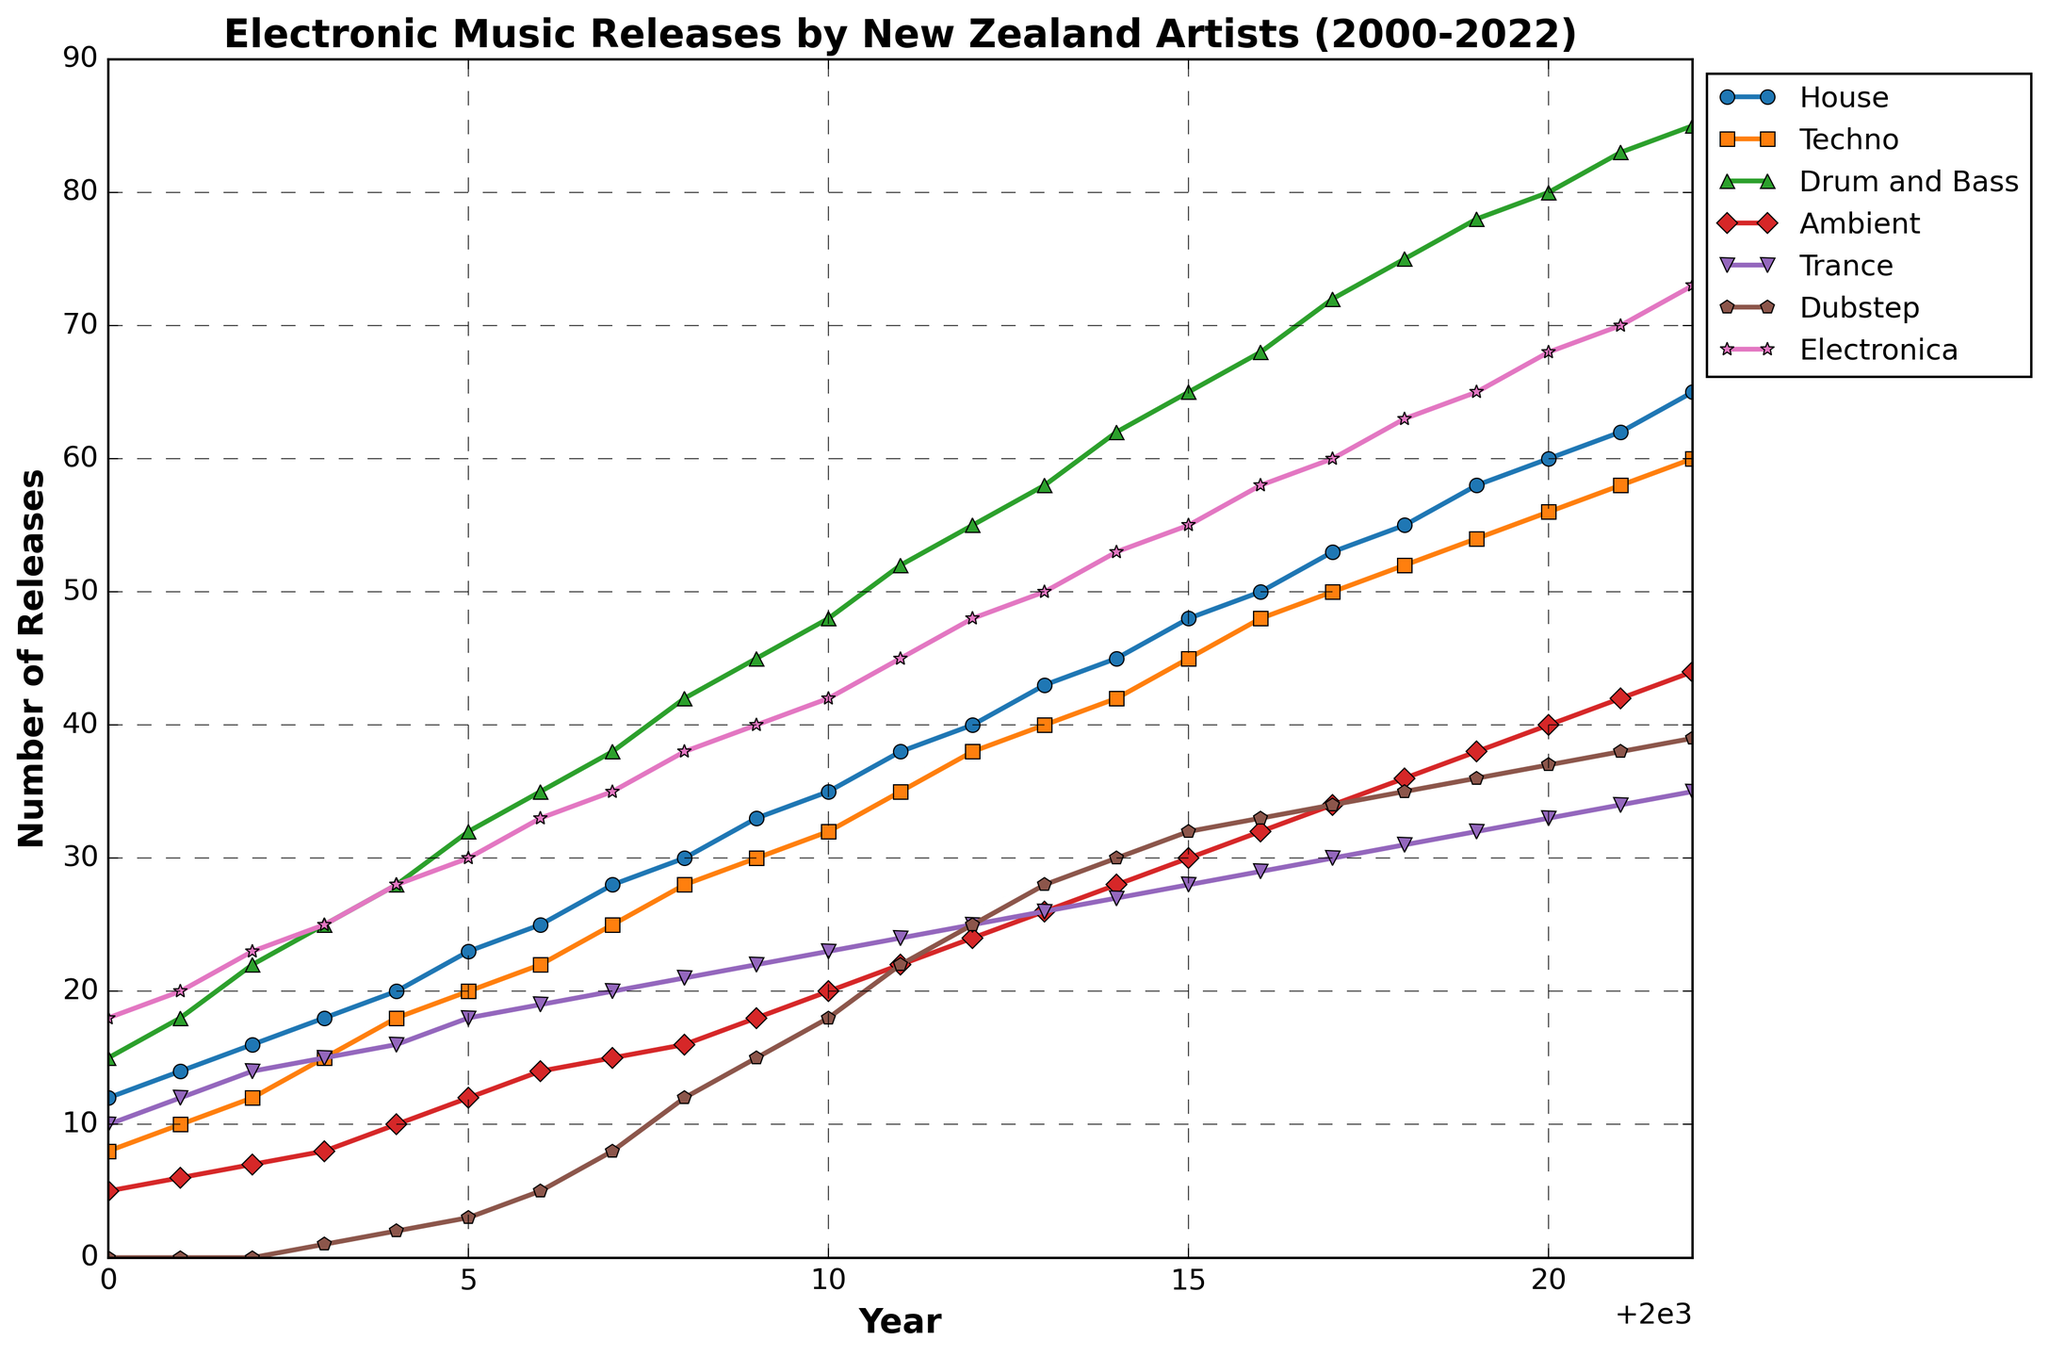What is the trend for the 'House' genre from 2000 to 2022? The 'House' genre shows a consistent increase in the number of releases each year, starting from 12 releases in 2000 to 65 releases in 2022.
Answer: Increasing trend Which year saw the highest number of 'Drum and Bass' releases and how many were there? In 2022, the 'Drum and Bass' genre saw the highest number of releases, with 85 releases.
Answer: 2022, 85 releases Compare the number of 'Techno' and 'Dubstep' releases in 2018. Which genre had more releases and by how much? In 2018, 'Techno' had 52 releases while 'Dubstep' had 35 releases. 'Techno' had 17 more releases than 'Dubstep'.
Answer: Techno, by 17 What is the difference in the number of 'Ambient' releases between the years 2000 and 2022? In 2000, there were 5 releases in 'Ambient' and in 2022, there were 44 releases. The difference is 44 - 5 = 39 releases.
Answer: 39 releases Which subgenre had the least number of releases in 2000 and what was the count? In 2000, the 'Dubstep' subgenre had the least number of releases with 0 releases.
Answer: Dubstep, 0 releases What are the total releases for all genres in 2020? Adding the releases for all genres in 2020 (60 for House, 56 for Techno, 80 for Drum and Bass, 40 for Ambient, 33 for Trance, 37 for Dubstep, and 68 for Electronica): 60 + 56 + 80 + 40 + 33 + 37 + 68 = 374.
Answer: 374 releases How many more 'Trance' releases were there in 2005 compared to 2003? In 2003, there were 15 'Trance' releases, and in 2005 there were 18 'Trance' releases. The difference is 18 - 15 = 3 releases.
Answer: 3 releases What is the average number of 'Electronica' releases from 2010 to 2022? Adding the releases for 'Electronica' from 2010 to 2022 (42, 45, 48, 50, 53, 55, 58, 60, 63, 65, 68, 70, 73) and then dividing by the number of years:
(42 + 45 + 48 + 50 + 53 + 55 + 58 + 60 + 63 + 65 + 68 + 70 + 73) / 13 = 53.69.
Answer: 53.69 releases Compare the growth rates of 'Drum and Bass' and 'Ambient' from 2000 to 2022. Which genre grew faster? 'Drum and Bass' grew from 15 releases in 2000 to 85 releases in 2022, an increase of 70 releases. 'Ambient' grew from 5 releases in 2000 to 44 releases in 2022, an increase of 39 releases. Hence, 'Drum and Bass' grew at a faster rate.
Answer: Drum and Bass Identify the genre with the most consistent yearly increase and justify your answer. 'House' shows a consistent yearly increase in the number of releases, with no dips in any year from 2000 to 2022, steadily rising from 12 to 65 releases.
Answer: House 